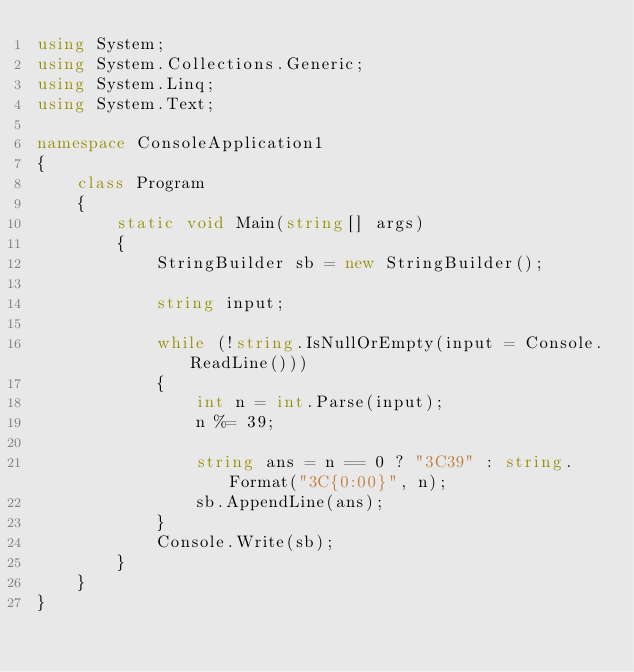<code> <loc_0><loc_0><loc_500><loc_500><_C#_>using System;
using System.Collections.Generic;
using System.Linq;
using System.Text;

namespace ConsoleApplication1
{
    class Program
    {
        static void Main(string[] args)
        {
            StringBuilder sb = new StringBuilder();

            string input;

            while (!string.IsNullOrEmpty(input = Console.ReadLine()))
            {
                int n = int.Parse(input);
                n %= 39;

                string ans = n == 0 ? "3C39" : string.Format("3C{0:00}", n);
                sb.AppendLine(ans);
            }
            Console.Write(sb);
        }
    }
}</code> 